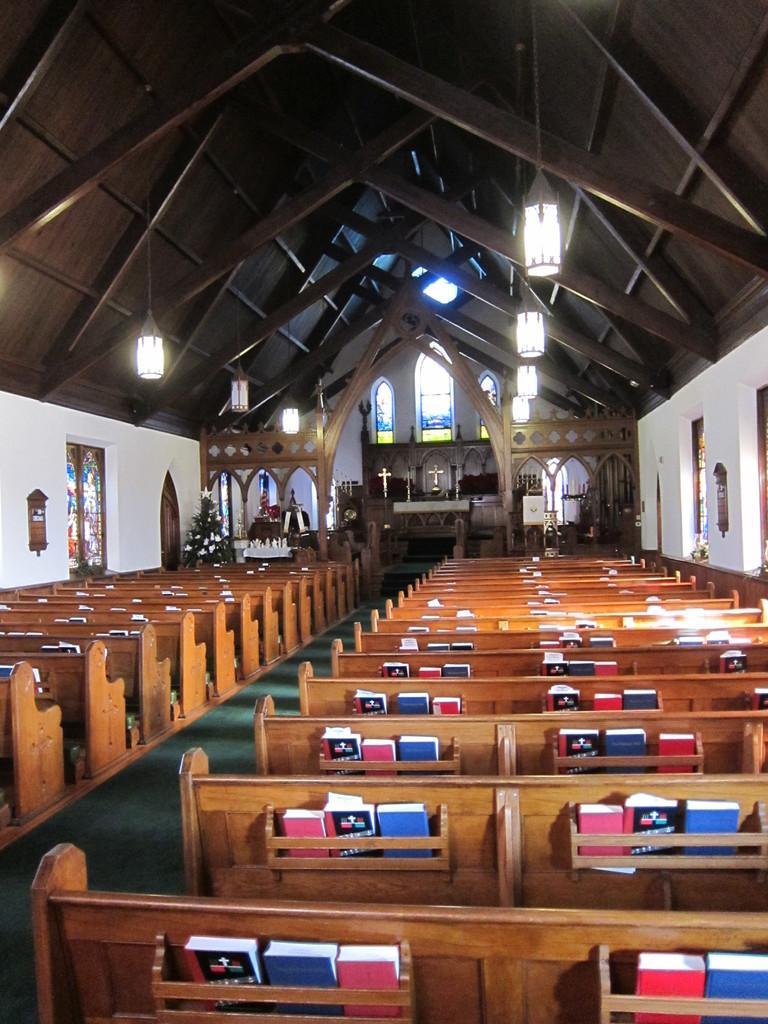Can you describe this image briefly? This picture is clicked inside the hall. In the foreground we can see the wooden benches and we can see the books. In the background we can see the wall and the Christmas tree and many other objects. At the top we can see the roof and the lights hanging on the roof and we can see the windows. 